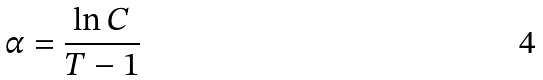Convert formula to latex. <formula><loc_0><loc_0><loc_500><loc_500>\alpha = \frac { \ln C } { T - 1 }</formula> 